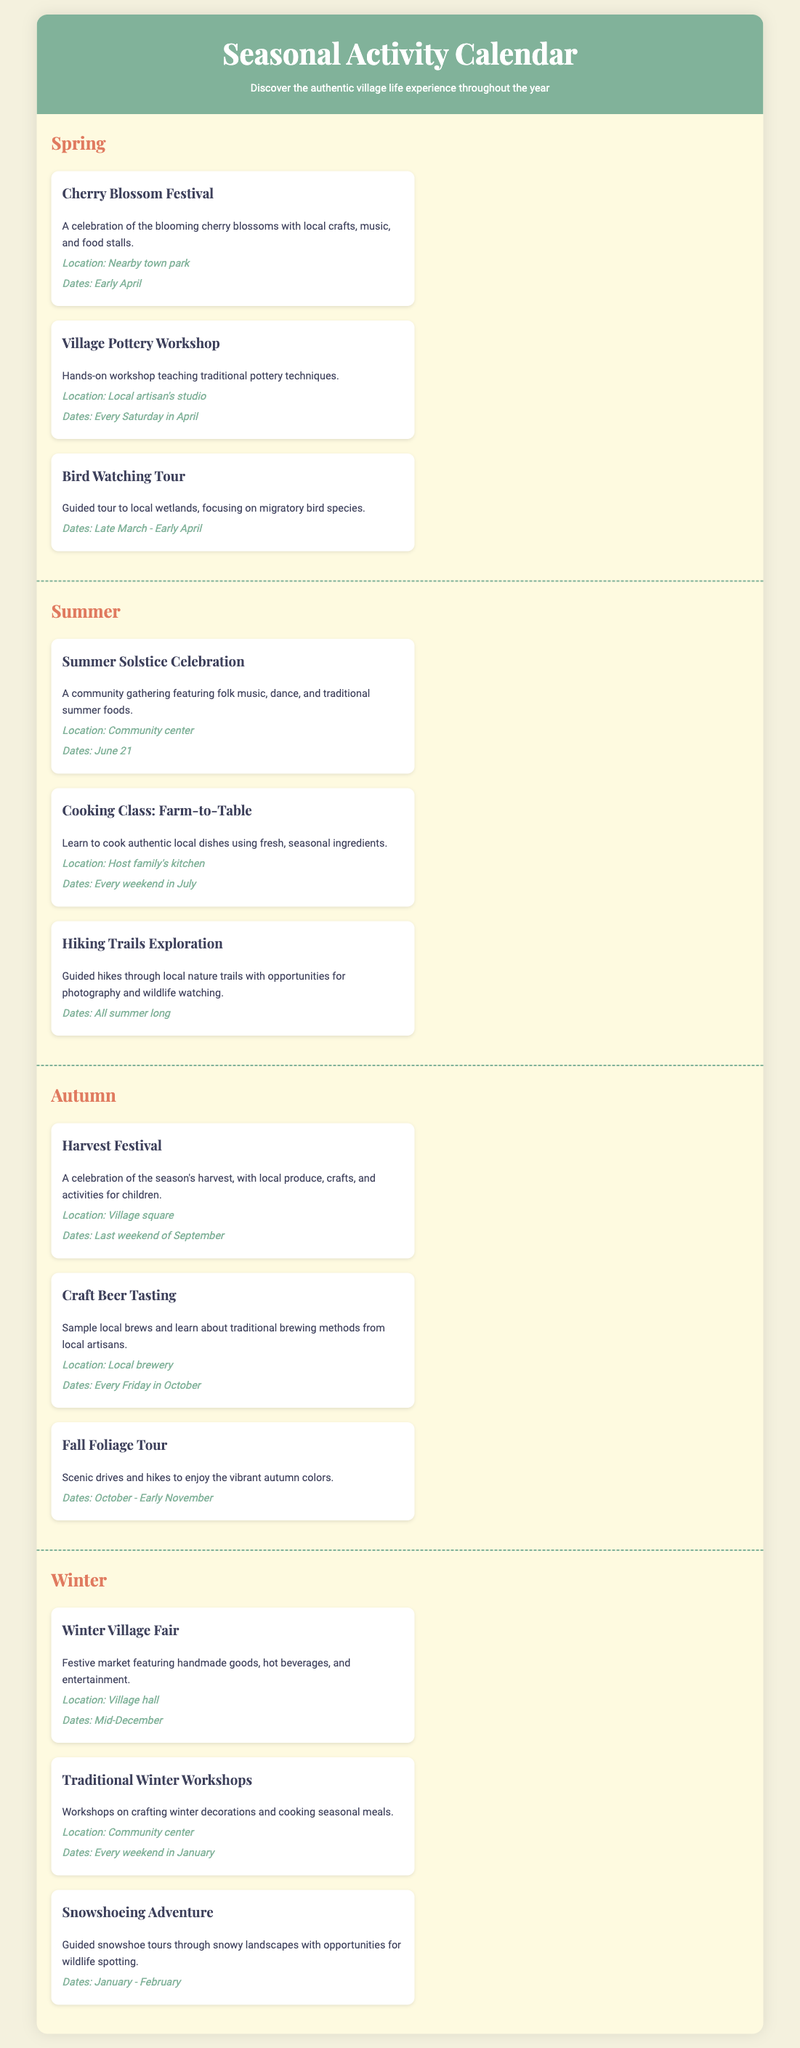What is the Cherry Blossom Festival? The Cherry Blossom Festival is a celebration of the blooming cherry blossoms with local crafts, music, and food stalls.
Answer: A celebration of the blooming cherry blossoms with local crafts, music, and food stalls When does the Harvest Festival take place? The Harvest Festival takes place on the last weekend of September.
Answer: Last weekend of September What type of workshop is offered every Saturday in April? The workshop offered every Saturday in April is a pottery workshop teaching traditional pottery techniques.
Answer: Village Pottery Workshop What activity occurs every weekend in January? The activity that occurs every weekend in January is the Traditional Winter Workshops on crafting winter decorations and cooking seasonal meals.
Answer: Traditional Winter Workshops Where is the Summer Solstice Celebration held? The Summer Solstice Celebration is held at the community center.
Answer: Community center How long does the Hiking Trails Exploration take place? The Hiking Trails Exploration takes place all summer long.
Answer: All summer long What are the dates for the Bird Watching Tour? The Bird Watching Tour is scheduled from late March to early April.
Answer: Late March - Early April What type of event is the Craft Beer Tasting? The Craft Beer Tasting is an event where participants sample local brews and learn about traditional brewing methods.
Answer: Sample local brews and learn about traditional brewing methods During which month is the Winter Village Fair held? The Winter Village Fair is held in mid-December.
Answer: Mid-December 